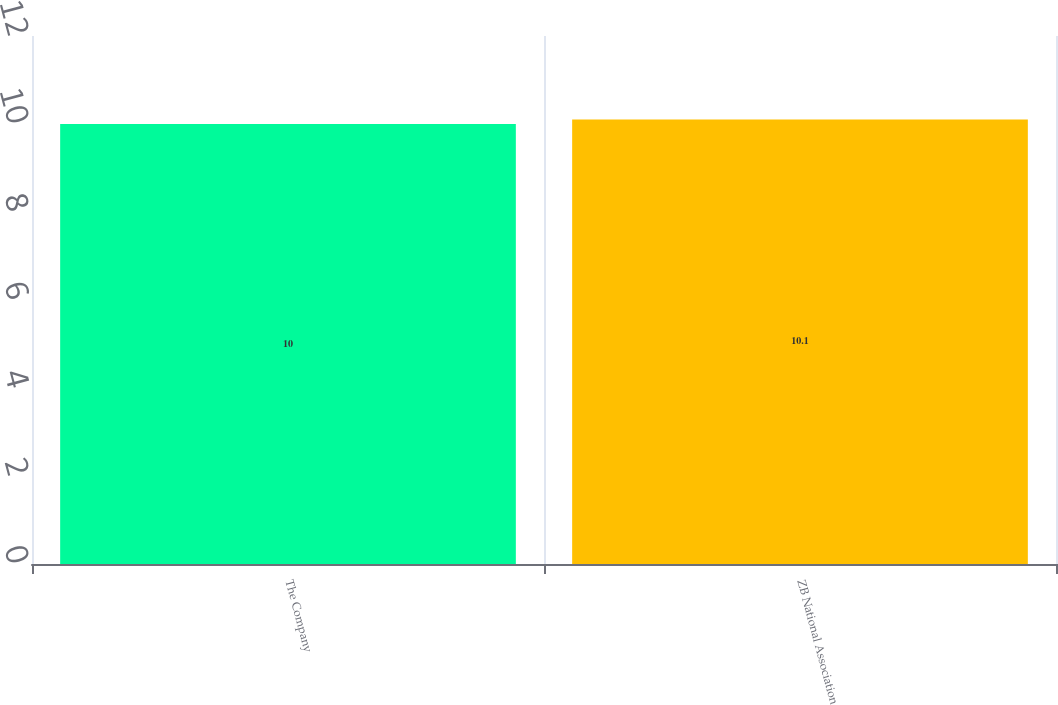<chart> <loc_0><loc_0><loc_500><loc_500><bar_chart><fcel>The Company<fcel>ZB National Association<nl><fcel>10<fcel>10.1<nl></chart> 